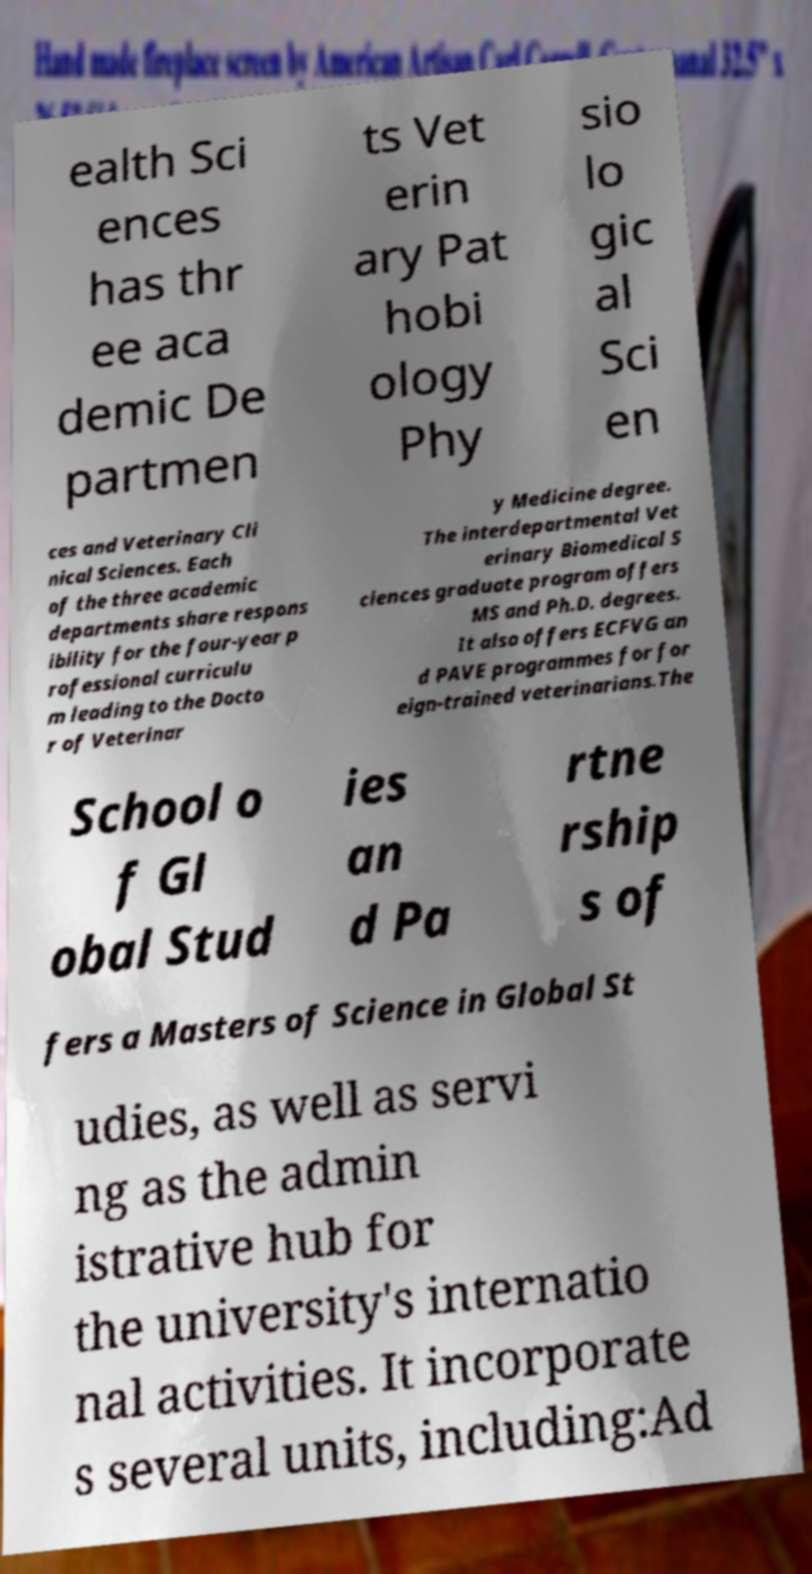I need the written content from this picture converted into text. Can you do that? ealth Sci ences has thr ee aca demic De partmen ts Vet erin ary Pat hobi ology Phy sio lo gic al Sci en ces and Veterinary Cli nical Sciences. Each of the three academic departments share respons ibility for the four-year p rofessional curriculu m leading to the Docto r of Veterinar y Medicine degree. The interdepartmental Vet erinary Biomedical S ciences graduate program offers MS and Ph.D. degrees. It also offers ECFVG an d PAVE programmes for for eign-trained veterinarians.The School o f Gl obal Stud ies an d Pa rtne rship s of fers a Masters of Science in Global St udies, as well as servi ng as the admin istrative hub for the university's internatio nal activities. It incorporate s several units, including:Ad 